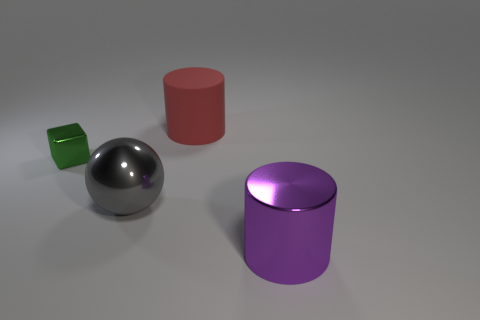What materials do the objects in the image seem to be made of? The objects in the image appear to be made of different types of polished metal, indicated by their reflective surfaces and luster.  Can you tell me more about the lighting in the scene? There seems to be a diffused light source illuminating the scene from above, creating soft shadows beneath the objects, which suggests an indoor setting, possibly using studio lighting. 